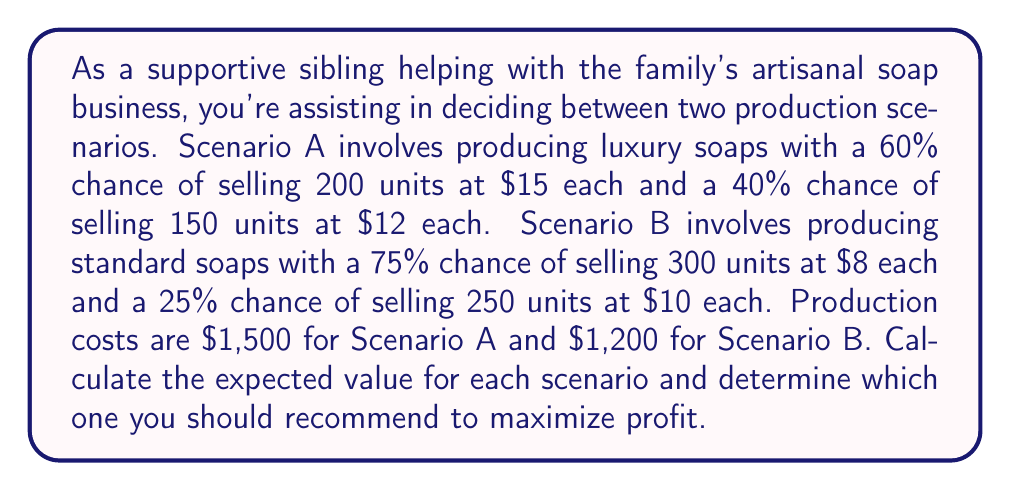Give your solution to this math problem. Let's break this problem down step-by-step:

1. Calculate the expected value for Scenario A:

   a) First outcome: $EV_A1 = 0.60 \times 200 \times \$15 = \$1,800$
   b) Second outcome: $EV_A2 = 0.40 \times 150 \times \$12 = \$720$
   c) Total expected revenue: $EV_A = EV_A1 + EV_A2 = \$1,800 + \$720 = \$2,520$
   d) Expected profit: $EV_A - \text{cost} = \$2,520 - \$1,500 = \$1,020$

2. Calculate the expected value for Scenario B:

   a) First outcome: $EV_B1 = 0.75 \times 300 \times \$8 = \$1,800$
   b) Second outcome: $EV_B2 = 0.25 \times 250 \times \$10 = \$625$
   c) Total expected revenue: $EV_B = EV_B1 + EV_B2 = \$1,800 + \$625 = \$2,425$
   d) Expected profit: $EV_B - \text{cost} = \$2,425 - \$1,200 = \$1,225$

3. Compare the expected profits:
   Scenario A: $\$1,020$
   Scenario B: $\$1,225$

Since Scenario B has a higher expected profit, it would be the recommended choice to maximize profit.
Answer: The expected value for Scenario A is $\$1,020$, and for Scenario B is $\$1,225$. You should recommend Scenario B (producing standard soaps) to maximize profit. 